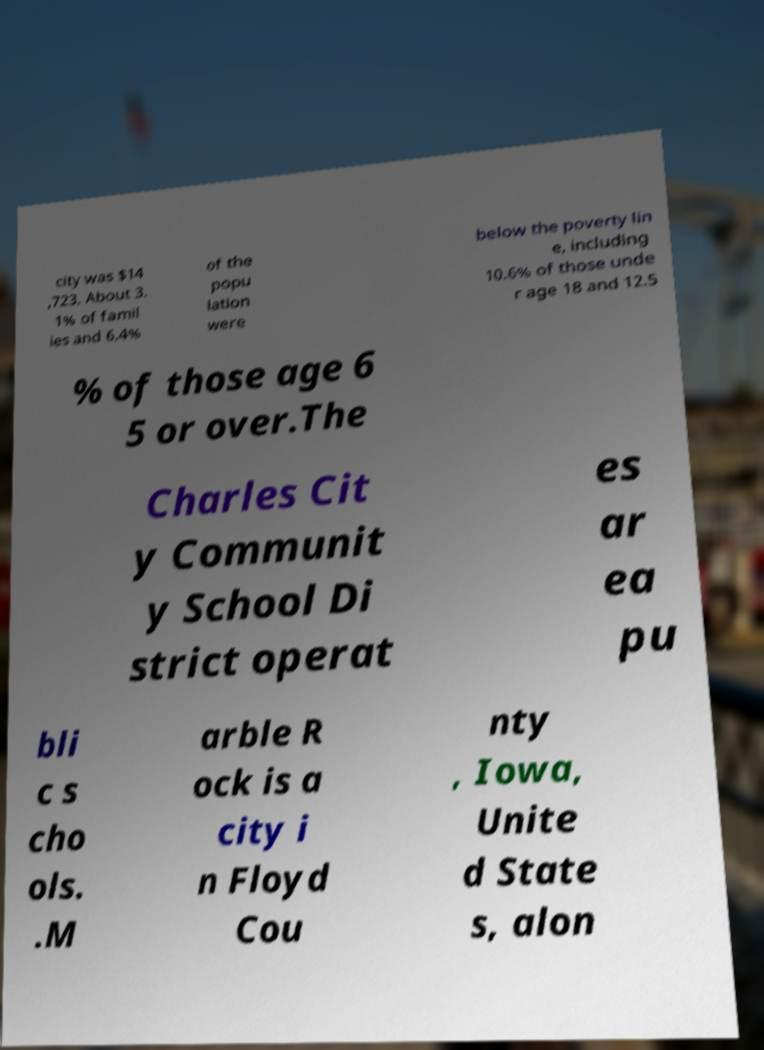I need the written content from this picture converted into text. Can you do that? city was $14 ,723. About 3. 1% of famil ies and 6.4% of the popu lation were below the poverty lin e, including 10.6% of those unde r age 18 and 12.5 % of those age 6 5 or over.The Charles Cit y Communit y School Di strict operat es ar ea pu bli c s cho ols. .M arble R ock is a city i n Floyd Cou nty , Iowa, Unite d State s, alon 